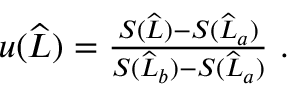Convert formula to latex. <formula><loc_0><loc_0><loc_500><loc_500>\begin{array} { r } { u ( \widehat { L } ) = \frac { S ( \widehat { L } ) - S ( \widehat { L } _ { a } ) } { S ( \widehat { L } _ { b } ) - S ( \widehat { L } _ { a } ) } \ . } \end{array}</formula> 